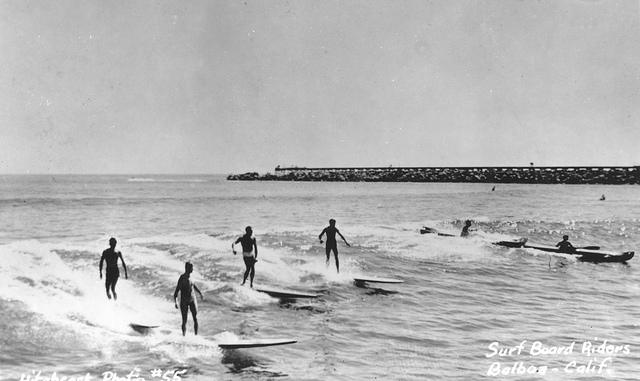Identify the text displayed in this image. Surf Riders Balbor Calif 